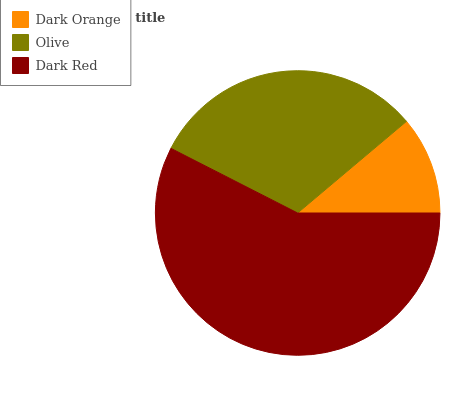Is Dark Orange the minimum?
Answer yes or no. Yes. Is Dark Red the maximum?
Answer yes or no. Yes. Is Olive the minimum?
Answer yes or no. No. Is Olive the maximum?
Answer yes or no. No. Is Olive greater than Dark Orange?
Answer yes or no. Yes. Is Dark Orange less than Olive?
Answer yes or no. Yes. Is Dark Orange greater than Olive?
Answer yes or no. No. Is Olive less than Dark Orange?
Answer yes or no. No. Is Olive the high median?
Answer yes or no. Yes. Is Olive the low median?
Answer yes or no. Yes. Is Dark Red the high median?
Answer yes or no. No. Is Dark Orange the low median?
Answer yes or no. No. 